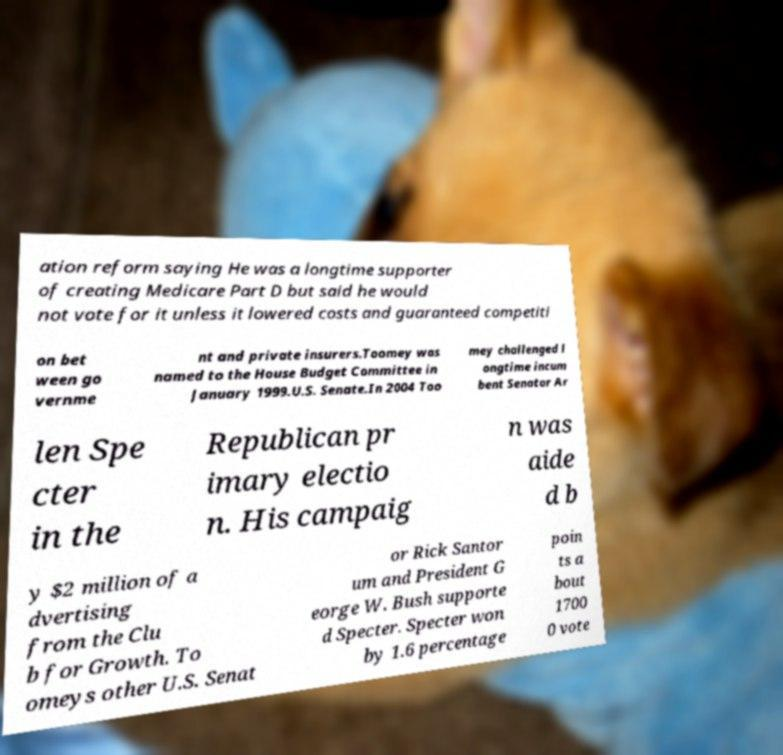Please read and relay the text visible in this image. What does it say? ation reform saying He was a longtime supporter of creating Medicare Part D but said he would not vote for it unless it lowered costs and guaranteed competiti on bet ween go vernme nt and private insurers.Toomey was named to the House Budget Committee in January 1999.U.S. Senate.In 2004 Too mey challenged l ongtime incum bent Senator Ar len Spe cter in the Republican pr imary electio n. His campaig n was aide d b y $2 million of a dvertising from the Clu b for Growth. To omeys other U.S. Senat or Rick Santor um and President G eorge W. Bush supporte d Specter. Specter won by 1.6 percentage poin ts a bout 1700 0 vote 